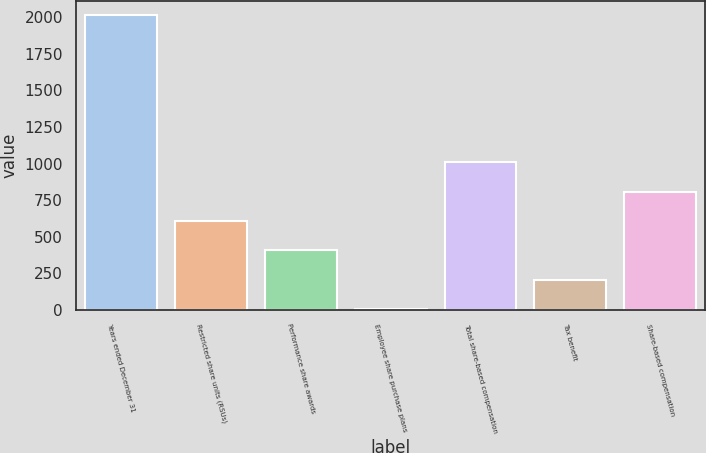Convert chart to OTSL. <chart><loc_0><loc_0><loc_500><loc_500><bar_chart><fcel>Years ended December 31<fcel>Restricted share units (RSUs)<fcel>Performance share awards<fcel>Employee share purchase plans<fcel>Total share-based compensation<fcel>Tax benefit<fcel>Share-based compensation<nl><fcel>2013<fcel>608.8<fcel>408.2<fcel>7<fcel>1010<fcel>207.6<fcel>809.4<nl></chart> 